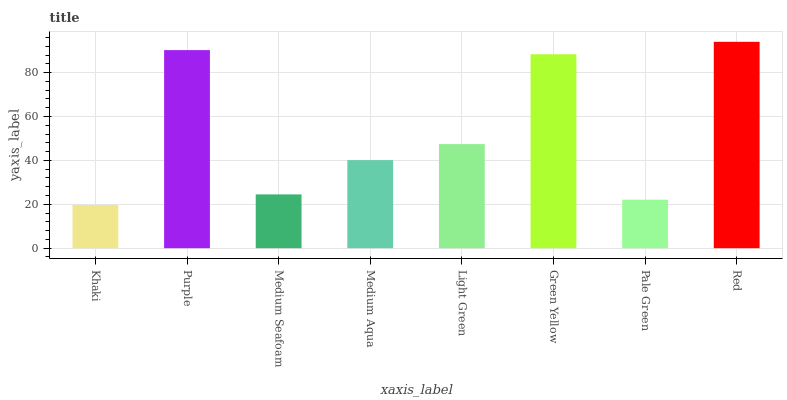Is Khaki the minimum?
Answer yes or no. Yes. Is Red the maximum?
Answer yes or no. Yes. Is Purple the minimum?
Answer yes or no. No. Is Purple the maximum?
Answer yes or no. No. Is Purple greater than Khaki?
Answer yes or no. Yes. Is Khaki less than Purple?
Answer yes or no. Yes. Is Khaki greater than Purple?
Answer yes or no. No. Is Purple less than Khaki?
Answer yes or no. No. Is Light Green the high median?
Answer yes or no. Yes. Is Medium Aqua the low median?
Answer yes or no. Yes. Is Pale Green the high median?
Answer yes or no. No. Is Green Yellow the low median?
Answer yes or no. No. 